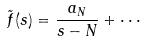<formula> <loc_0><loc_0><loc_500><loc_500>\tilde { f } ( s ) = \frac { a _ { N } } { s - N } + \cdot \cdot \cdot</formula> 